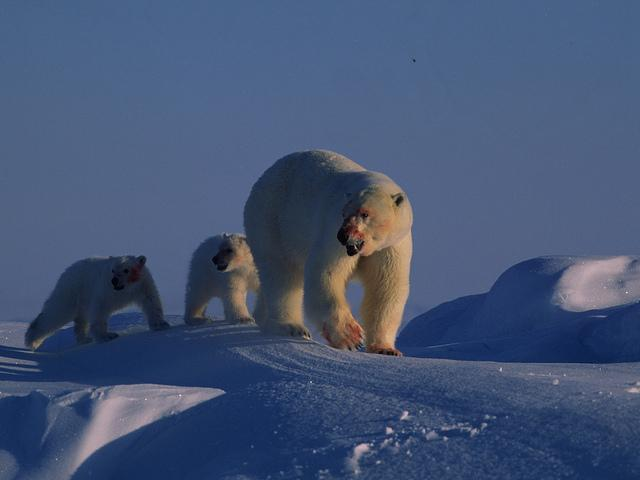Red on this bears face comes from it's what? blood 